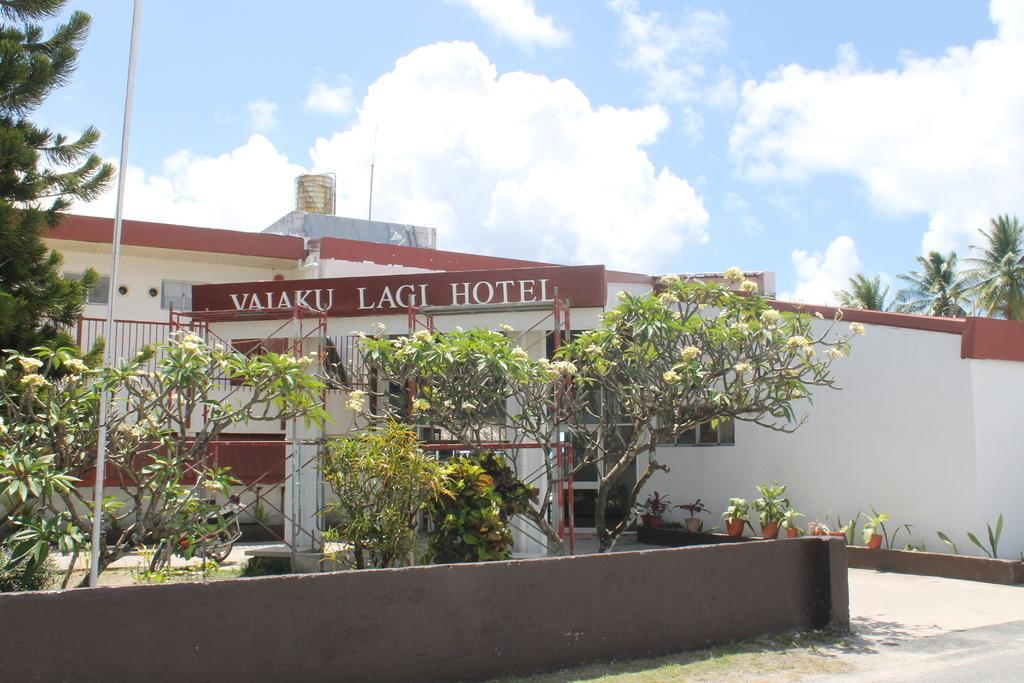What type of vegetation is on the left side of the image? There are green trees on the left side of the image. What structure is located in the middle of the image? There is a hotel in the middle of the image. What is the color of the hotel? The hotel is white in color. What is visible at the top of the image? The sky is visible at the top of the image. What is the weather like in the image? The sky is sunny, indicating a clear and bright day. Can you see any toes in the image? There are no toes visible in the image. What type of bread is being served at the hotel in the image? There is no bread or any indication of food being served in the image. 